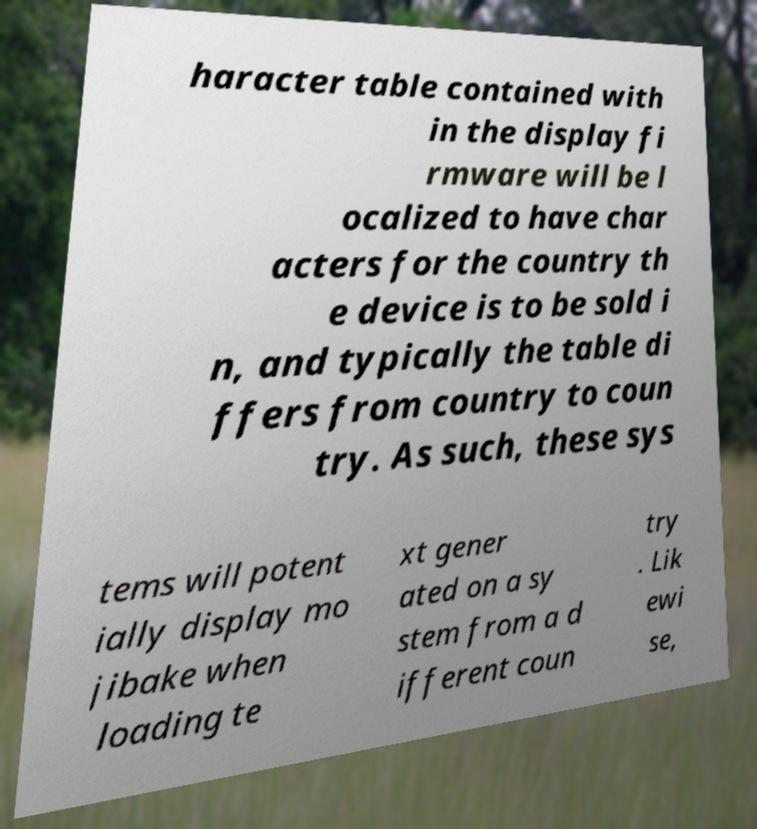Could you assist in decoding the text presented in this image and type it out clearly? haracter table contained with in the display fi rmware will be l ocalized to have char acters for the country th e device is to be sold i n, and typically the table di ffers from country to coun try. As such, these sys tems will potent ially display mo jibake when loading te xt gener ated on a sy stem from a d ifferent coun try . Lik ewi se, 